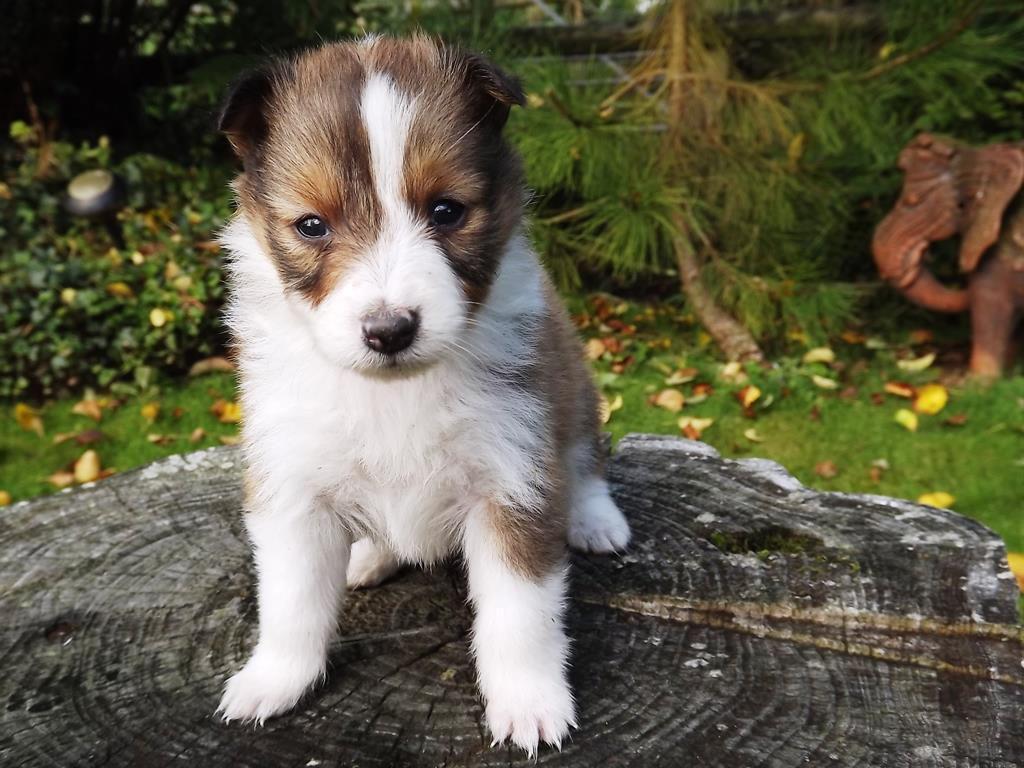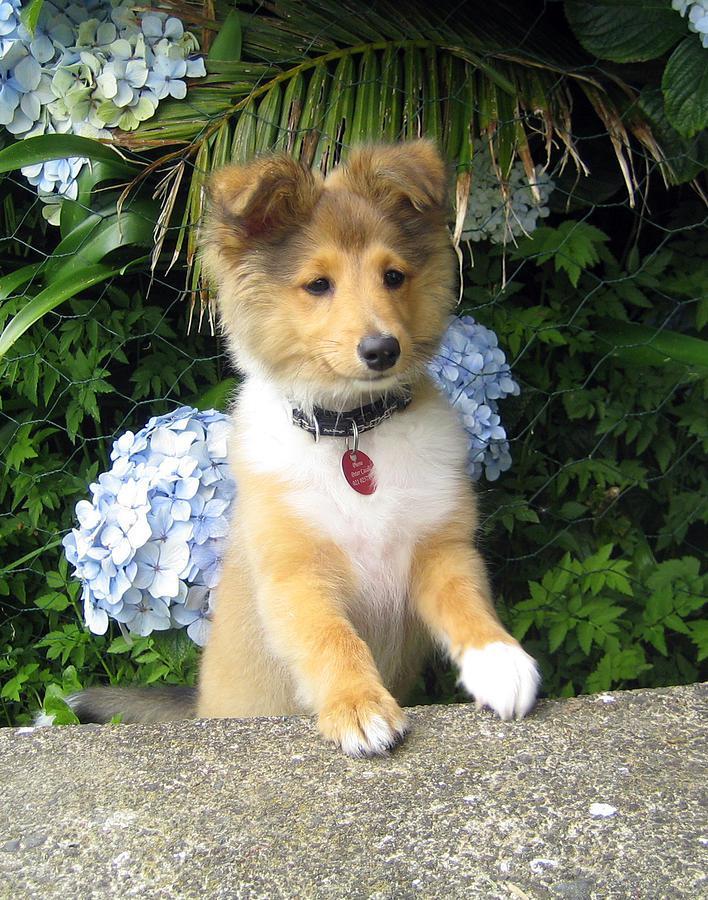The first image is the image on the left, the second image is the image on the right. Assess this claim about the two images: "An image shows a young pup sitting on a cut stump.". Correct or not? Answer yes or no. Yes. 